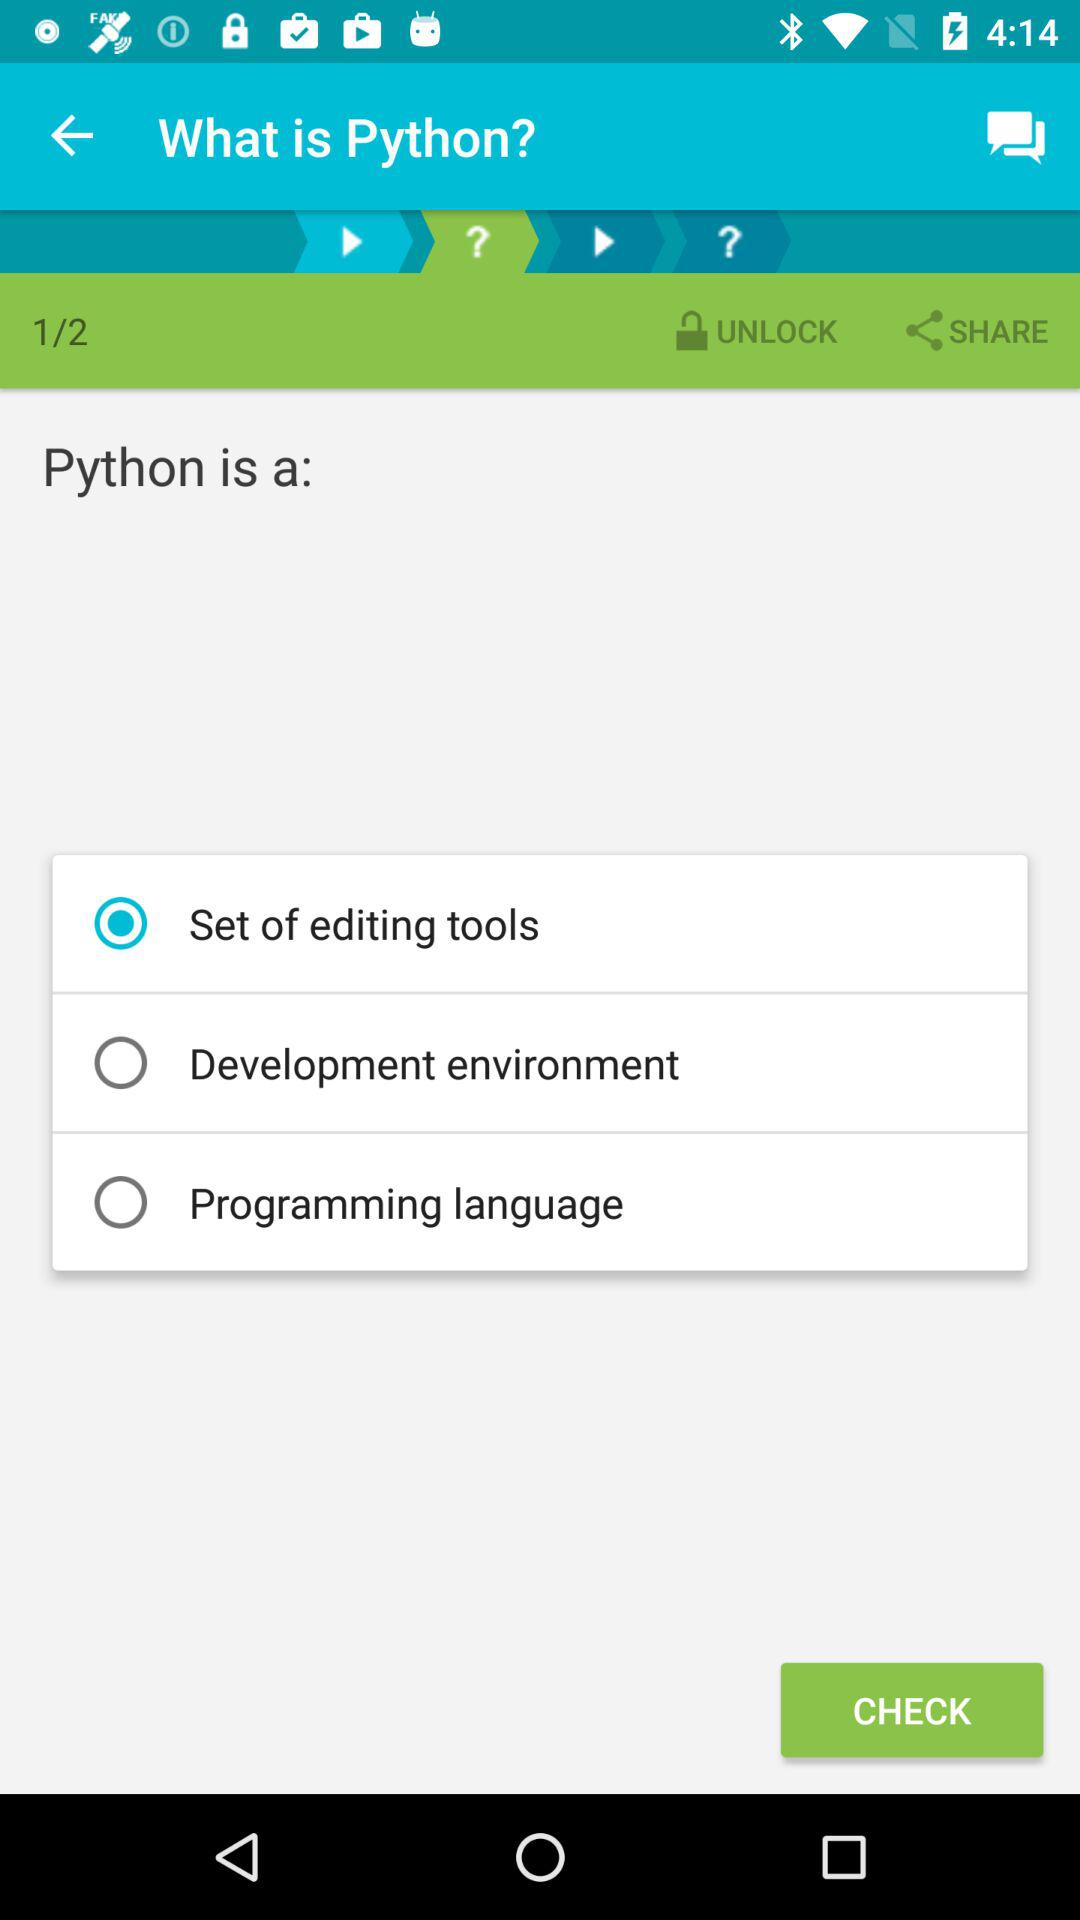How many sets are available in total? There are 2 sets available in total. 